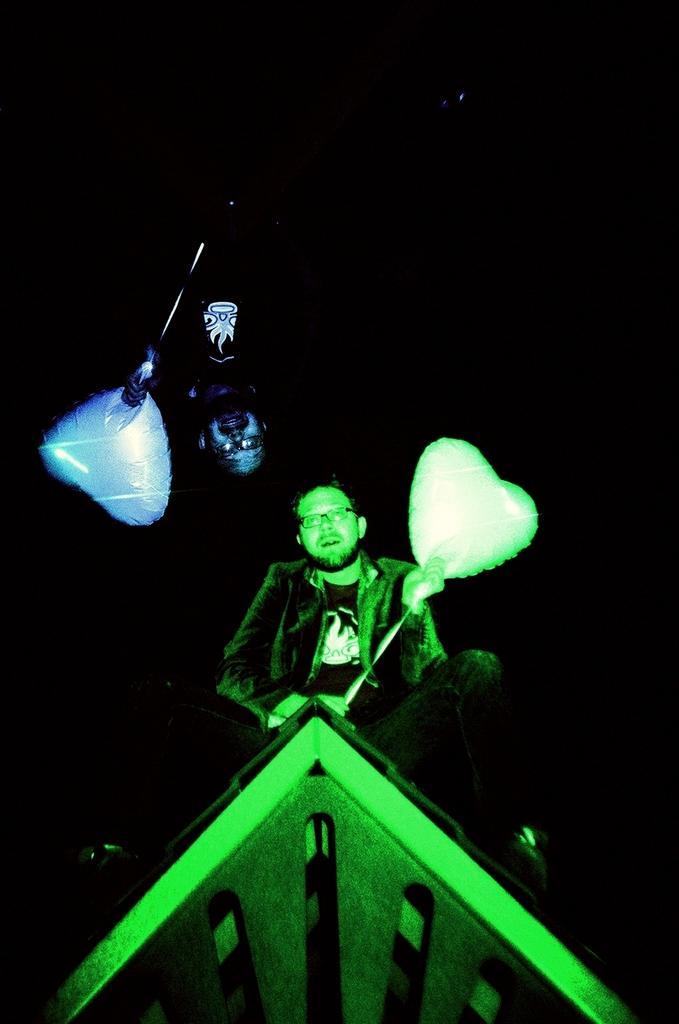Can you describe this image briefly? Here we can see two persons are holding balloons. There is a dark background. 